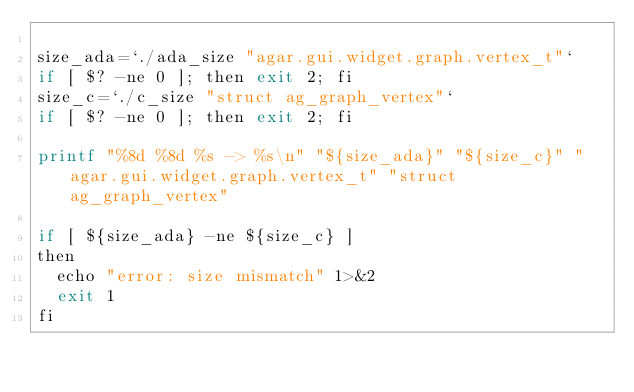<code> <loc_0><loc_0><loc_500><loc_500><_Perl_>
size_ada=`./ada_size "agar.gui.widget.graph.vertex_t"`
if [ $? -ne 0 ]; then exit 2; fi
size_c=`./c_size "struct ag_graph_vertex"`
if [ $? -ne 0 ]; then exit 2; fi

printf "%8d %8d %s -> %s\n" "${size_ada}" "${size_c}" "agar.gui.widget.graph.vertex_t" "struct ag_graph_vertex"

if [ ${size_ada} -ne ${size_c} ]
then
  echo "error: size mismatch" 1>&2
  exit 1
fi
</code> 